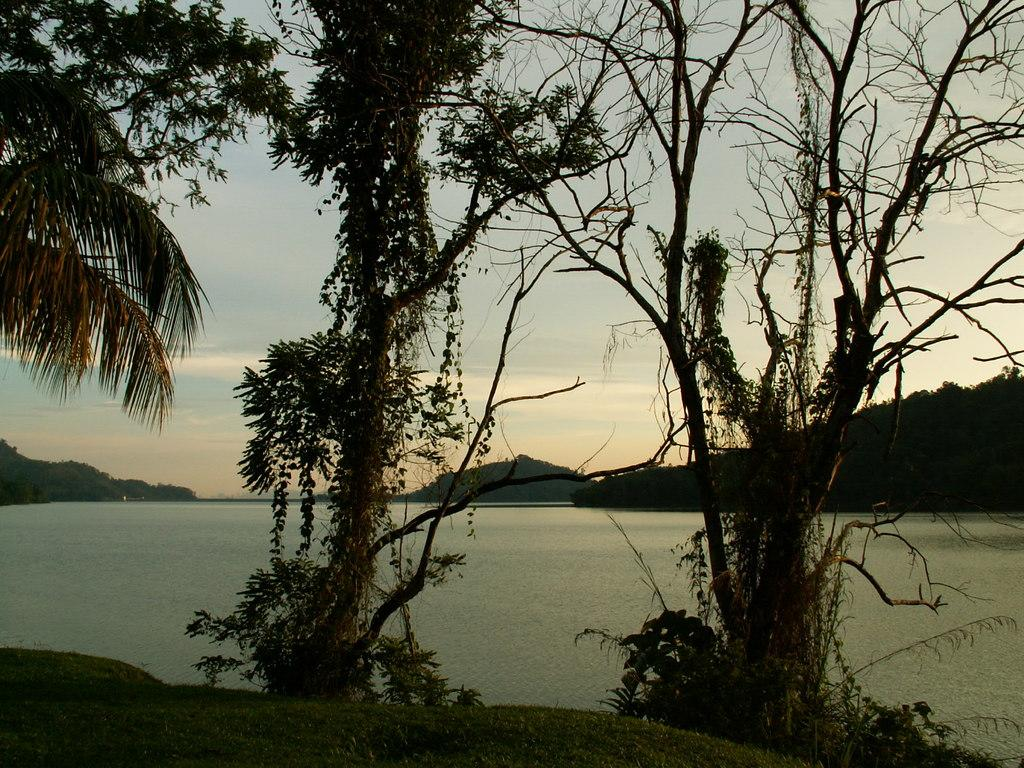What type of vegetation can be seen in the image? There are trees in the image. What natural element is visible in the image besides the trees? There is water visible in the image. What can be seen in the distance in the background of the image? There is a mountain in the background of the image. What else is visible in the background of the image? The sky is visible in the background of the image. What title is given to the mountain in the image? There is no title given to the mountain in the image; it is simply a mountain in the background. Can you describe the romantic interaction between the trees and the water in the image? There is no romantic interaction between the trees and the water in the image; they are separate elements in the scene. 